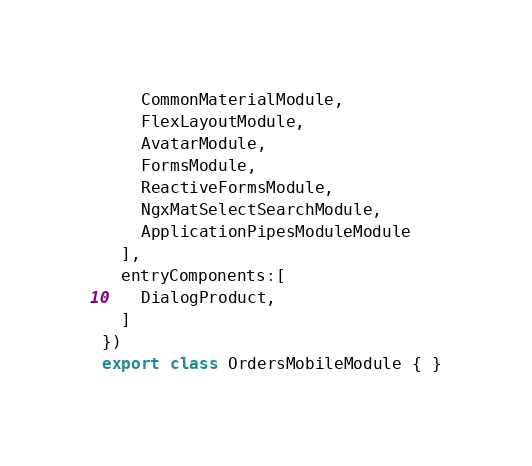Convert code to text. <code><loc_0><loc_0><loc_500><loc_500><_TypeScript_>    CommonMaterialModule,
    FlexLayoutModule,
    AvatarModule,
    FormsModule,
    ReactiveFormsModule,
    NgxMatSelectSearchModule,
    ApplicationPipesModuleModule
  ],
  entryComponents:[
    DialogProduct,
  ]
})
export class OrdersMobileModule { }
</code> 